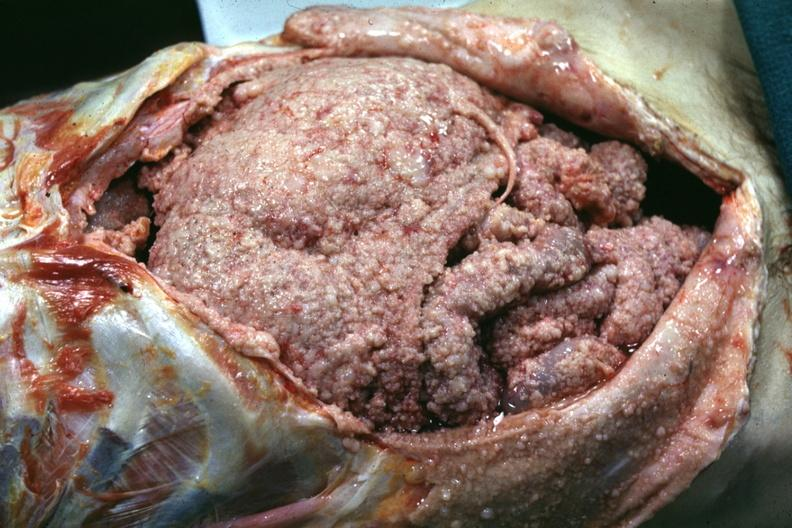what is present?
Answer the question using a single word or phrase. Abdomen 